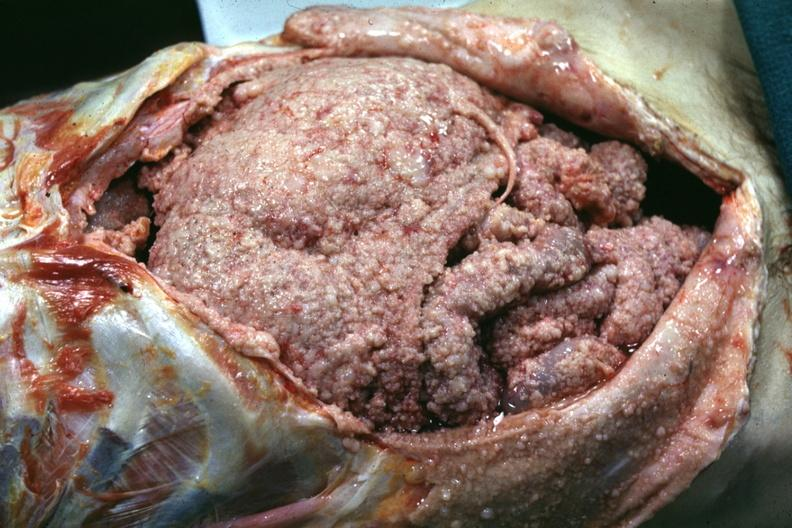what is present?
Answer the question using a single word or phrase. Abdomen 